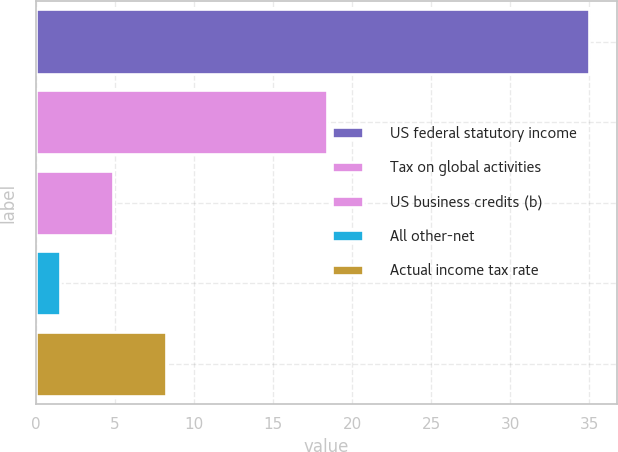Convert chart to OTSL. <chart><loc_0><loc_0><loc_500><loc_500><bar_chart><fcel>US federal statutory income<fcel>Tax on global activities<fcel>US business credits (b)<fcel>All other-net<fcel>Actual income tax rate<nl><fcel>35<fcel>18.4<fcel>4.85<fcel>1.5<fcel>8.2<nl></chart> 